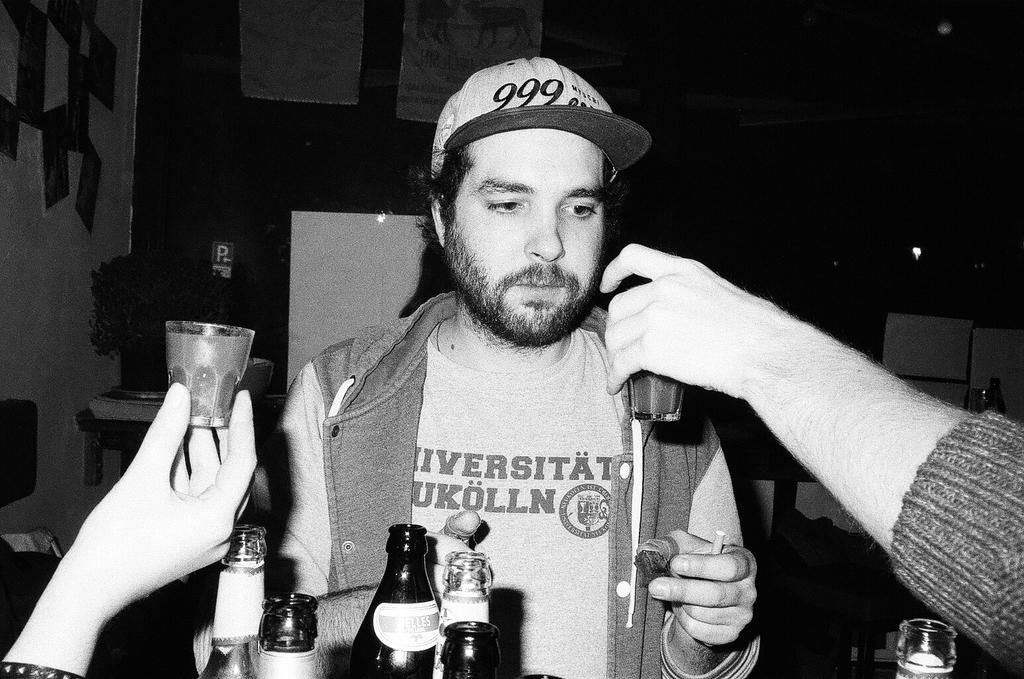Who is the main subject in the image? There is a man in the center of the image. What is the man holding in his hand? The man is holding something in his hand, but the specific object is not mentioned in the facts. What can be seen on the right side of the image? There is a hand on the right side of the image. What is the hand holding? The hand is holding a cup. What type of stick is the man using to burn the reward in the image? There is no stick, burning, or reward present in the image. 